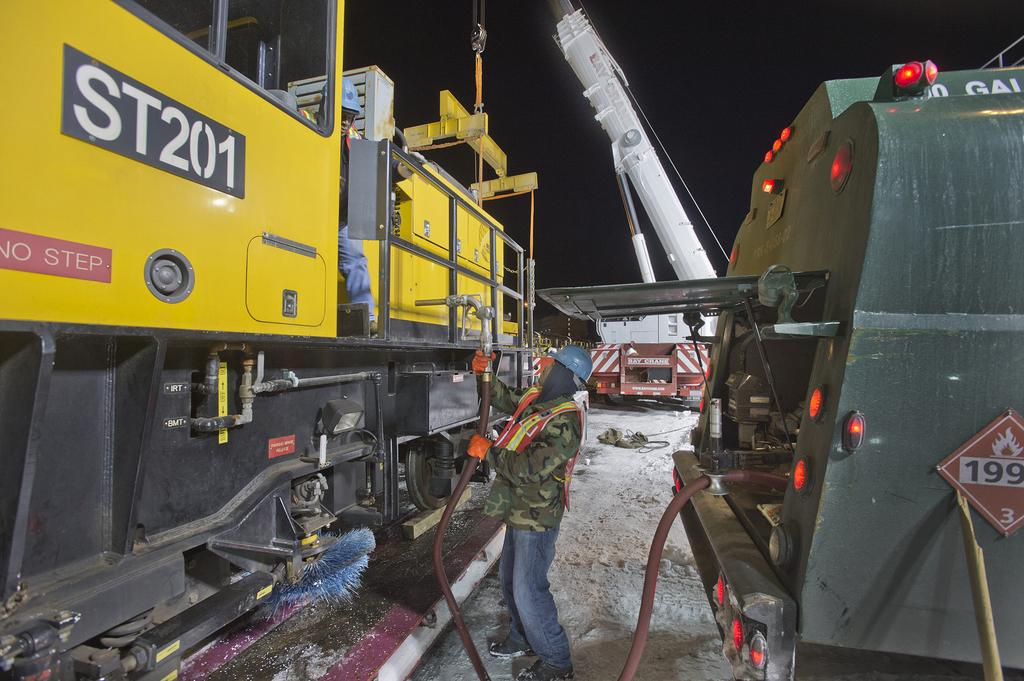<image>
Write a terse but informative summary of the picture. the letters ST are on the yellow item next to the people 